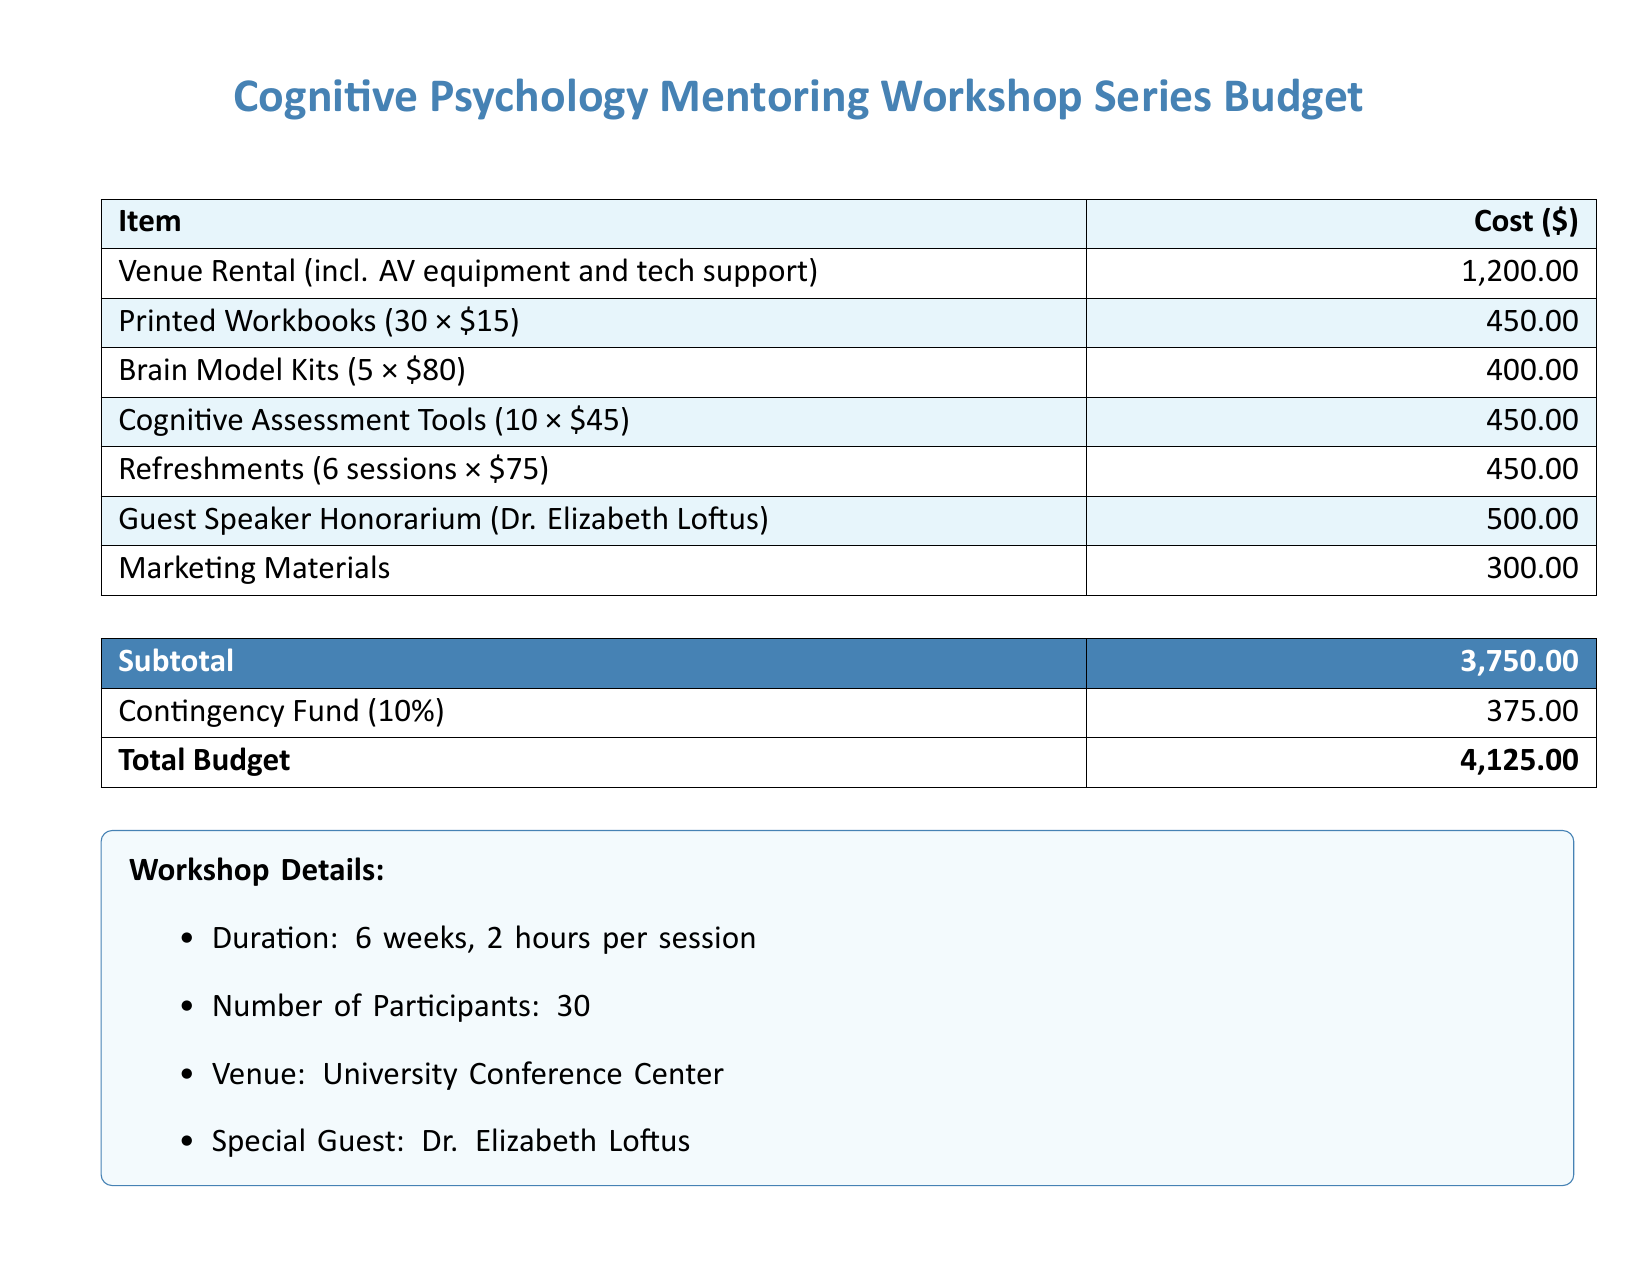What is the total budget? The total budget is provided at the end of the budget table, which includes subtotal and contingency fund.
Answer: 4,125.00 How much is allocated for venue rental? The budget specifies the cost for venue rental, including AV equipment and tech support.
Answer: 1,200.00 Who is the special guest speaker? The special guest speaker is mentioned in the workshop details section of the document.
Answer: Dr. Elizabeth Loftus How many printed workbooks are being purchased? The number of printed workbooks is specified in the budget breakdown.
Answer: 30 What is the contingency fund percentage? The document states that the contingency fund is calculated at a percentage of the subtotal.
Answer: 10% How many sessions are included in the workshop? The workshop duration and structure detail the number of sessions planned.
Answer: 6 What is the cost of the Brain Model Kits? The budget outlines the cost per unit and the quantity for the Brain Model Kits.
Answer: 400.00 What is the total cost for refreshments? The cost for refreshments is calculated based on the number of sessions and their individual costs.
Answer: 450.00 What is the cost for marketing materials? The budget specifically lists the allocated cost for marketing materials.
Answer: 300.00 